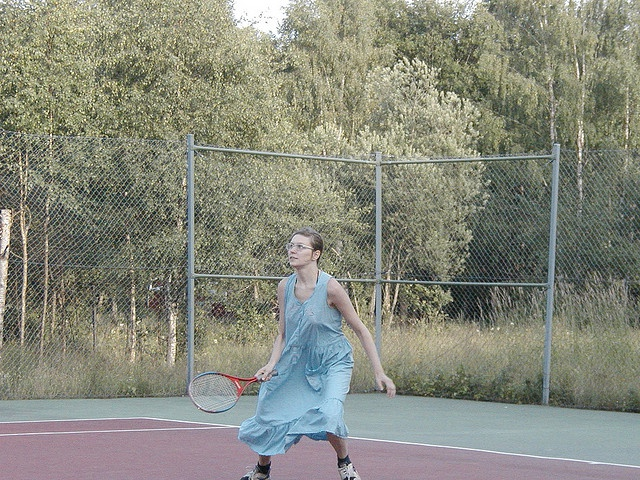Describe the objects in this image and their specific colors. I can see people in white, darkgray, gray, and lightblue tones and tennis racket in white, darkgray, gray, brown, and lightgray tones in this image. 